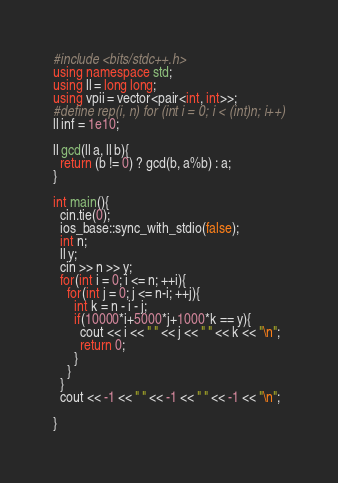<code> <loc_0><loc_0><loc_500><loc_500><_C++_>#include <bits/stdc++.h>
using namespace std;
using ll = long long; 
using vpii = vector<pair<int, int>>;
#define rep(i, n) for (int i = 0; i < (int)n; i++)
ll inf = 1e10;

ll gcd(ll a, ll b){
  return (b != 0) ? gcd(b, a%b) : a;
}

int main(){
  cin.tie(0);
  ios_base::sync_with_stdio(false);
  int n;
  ll y;
  cin >> n >> y;
  for(int i = 0; i <= n; ++i){
    for(int j = 0; j <= n-i; ++j){
      int k = n - i - j;
      if(10000*i+5000*j+1000*k == y){
        cout << i << " " << j << " " << k << "\n";
        return 0;
      }
    }
  }
  cout << -1 << " " << -1 << " " << -1 << "\n";
  
}  </code> 